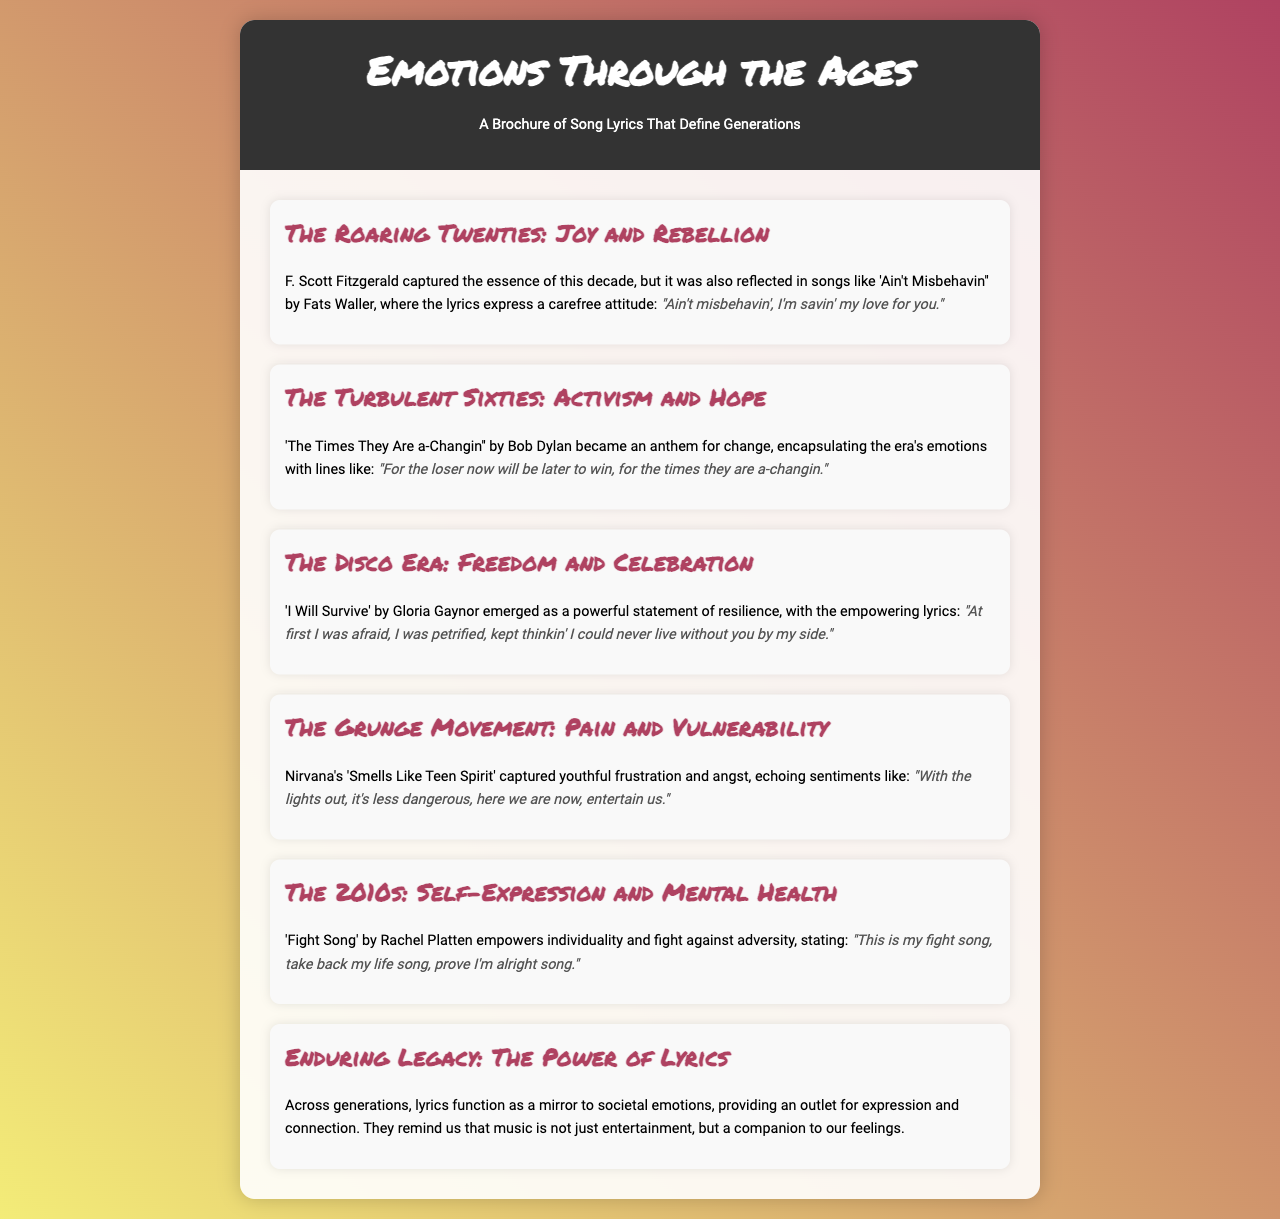What song symbolizes the carefree attitude of the Roaring Twenties? The brochure mentions 'Ain't Misbehavin'' by Fats Waller as a reflection of the Roaring Twenties.
Answer: Ain't Misbehavin' Which decade is represented by 'The Times They Are a-Changin''? The song by Bob Dylan encapsulates the emotions of the Turbulent Sixties.
Answer: The Turbulent Sixties What emotion is associated with the song 'I Will Survive'? The lyrics express themes of resilience and empowerment during the Disco Era.
Answer: Resilience What notable lyric is from Nirvana's 'Smells Like Teen Spirit'? The document quotes, "With the lights out, it's less dangerous, here we are now, entertain us."
Answer: "With the lights out, it's less dangerous, here we are now, entertain us." What is the focus of the section titled 'Enduring Legacy: The Power of Lyrics'? This section discusses how lyrics mirror societal emotions and provide an outlet for expression.
Answer: Societal emotions How does 'Fight Song' by Rachel Platten relate to the 2010s? The song empowers individuality and encourages fighting against adversity.
Answer: Individuality and adversity What color scheme is used in the brochure design? The background features a gradient of yellow and red shades.
Answer: Yellow and red How many sections are in the brochure? There are six distinct sections presenting various themes and songs.
Answer: Six 